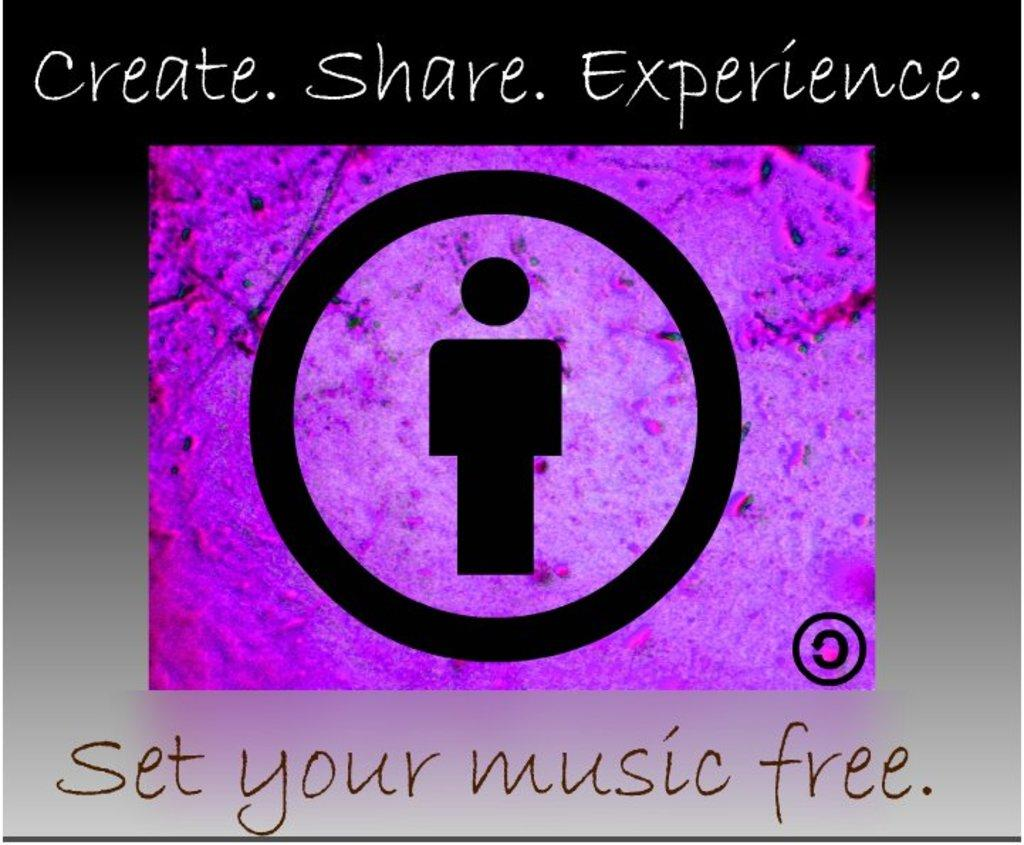Provide a one-sentence caption for the provided image. An ad imploring the reader to set their music free. 